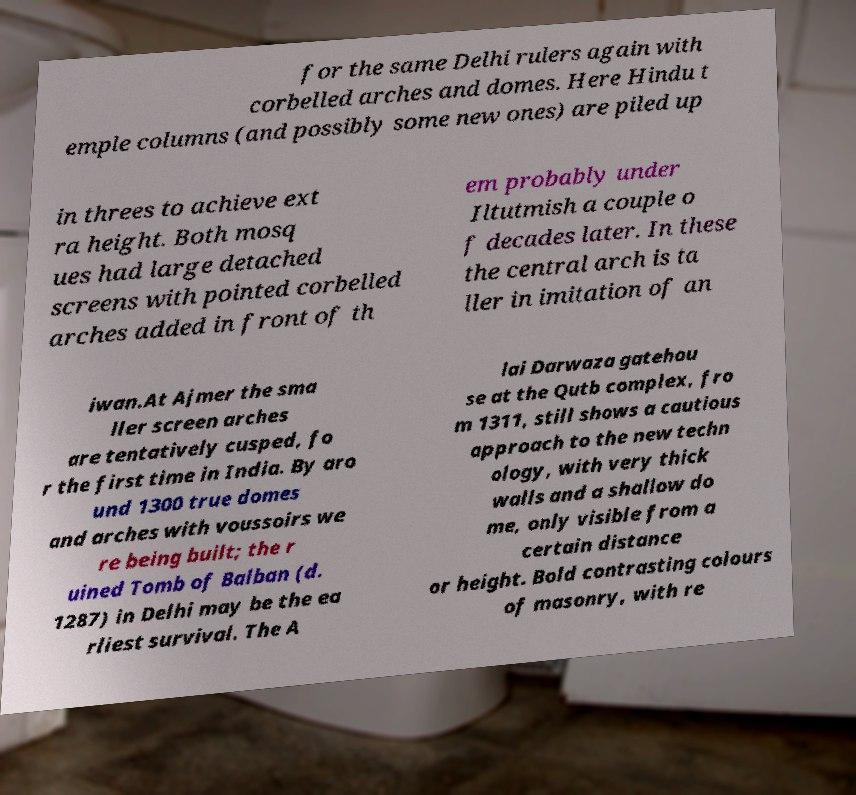For documentation purposes, I need the text within this image transcribed. Could you provide that? for the same Delhi rulers again with corbelled arches and domes. Here Hindu t emple columns (and possibly some new ones) are piled up in threes to achieve ext ra height. Both mosq ues had large detached screens with pointed corbelled arches added in front of th em probably under Iltutmish a couple o f decades later. In these the central arch is ta ller in imitation of an iwan.At Ajmer the sma ller screen arches are tentatively cusped, fo r the first time in India. By aro und 1300 true domes and arches with voussoirs we re being built; the r uined Tomb of Balban (d. 1287) in Delhi may be the ea rliest survival. The A lai Darwaza gatehou se at the Qutb complex, fro m 1311, still shows a cautious approach to the new techn ology, with very thick walls and a shallow do me, only visible from a certain distance or height. Bold contrasting colours of masonry, with re 